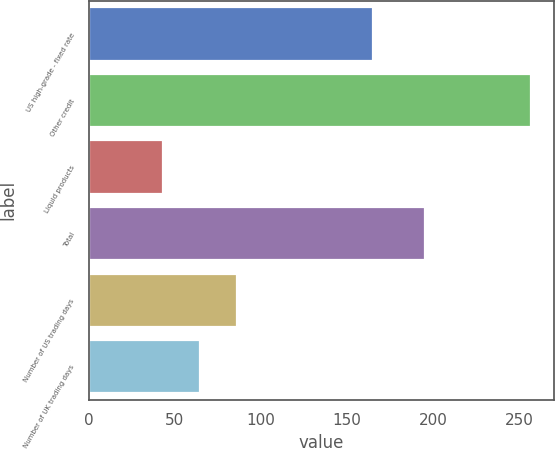Convert chart to OTSL. <chart><loc_0><loc_0><loc_500><loc_500><bar_chart><fcel>US high-grade - fixed rate<fcel>Other credit<fcel>Liquid products<fcel>Total<fcel>Number of US trading days<fcel>Number of UK trading days<nl><fcel>165<fcel>257<fcel>43<fcel>195<fcel>85.8<fcel>64.4<nl></chart> 